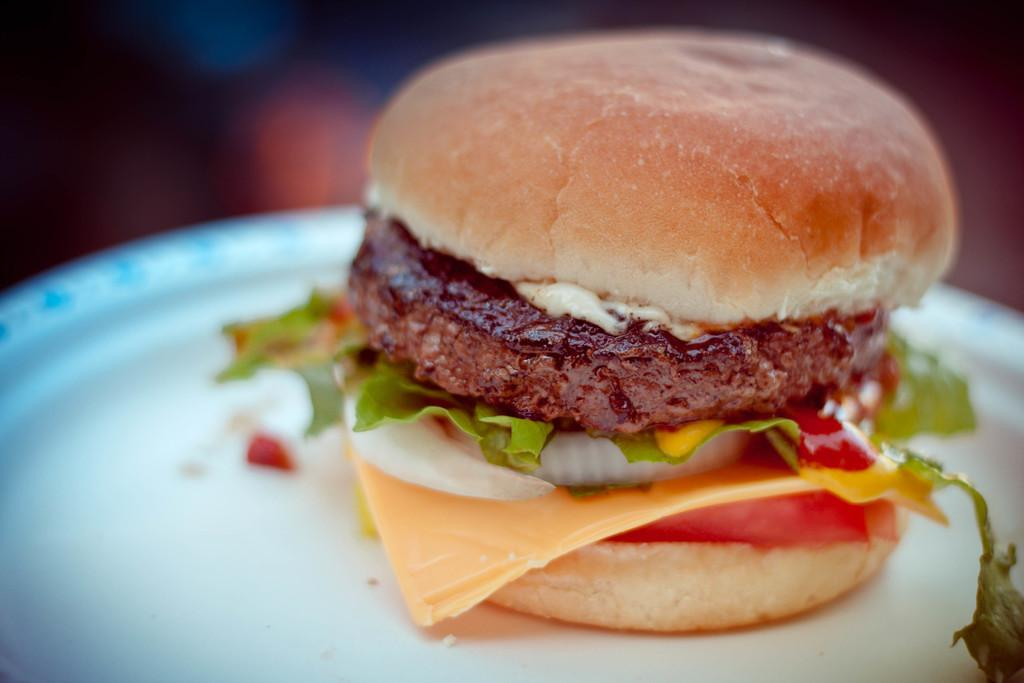What type of food is the main subject of the image? There is a burger in the image. How is the burger presented in the image? The burger is on a white plate. Can you describe the background of the image? There is a blurred image in the image in the background of the picture. What type of vegetable is being used as a glove in the image? There is no vegetable being used as a glove in the image, as the image only features a burger on a white plate with a blurred background. 